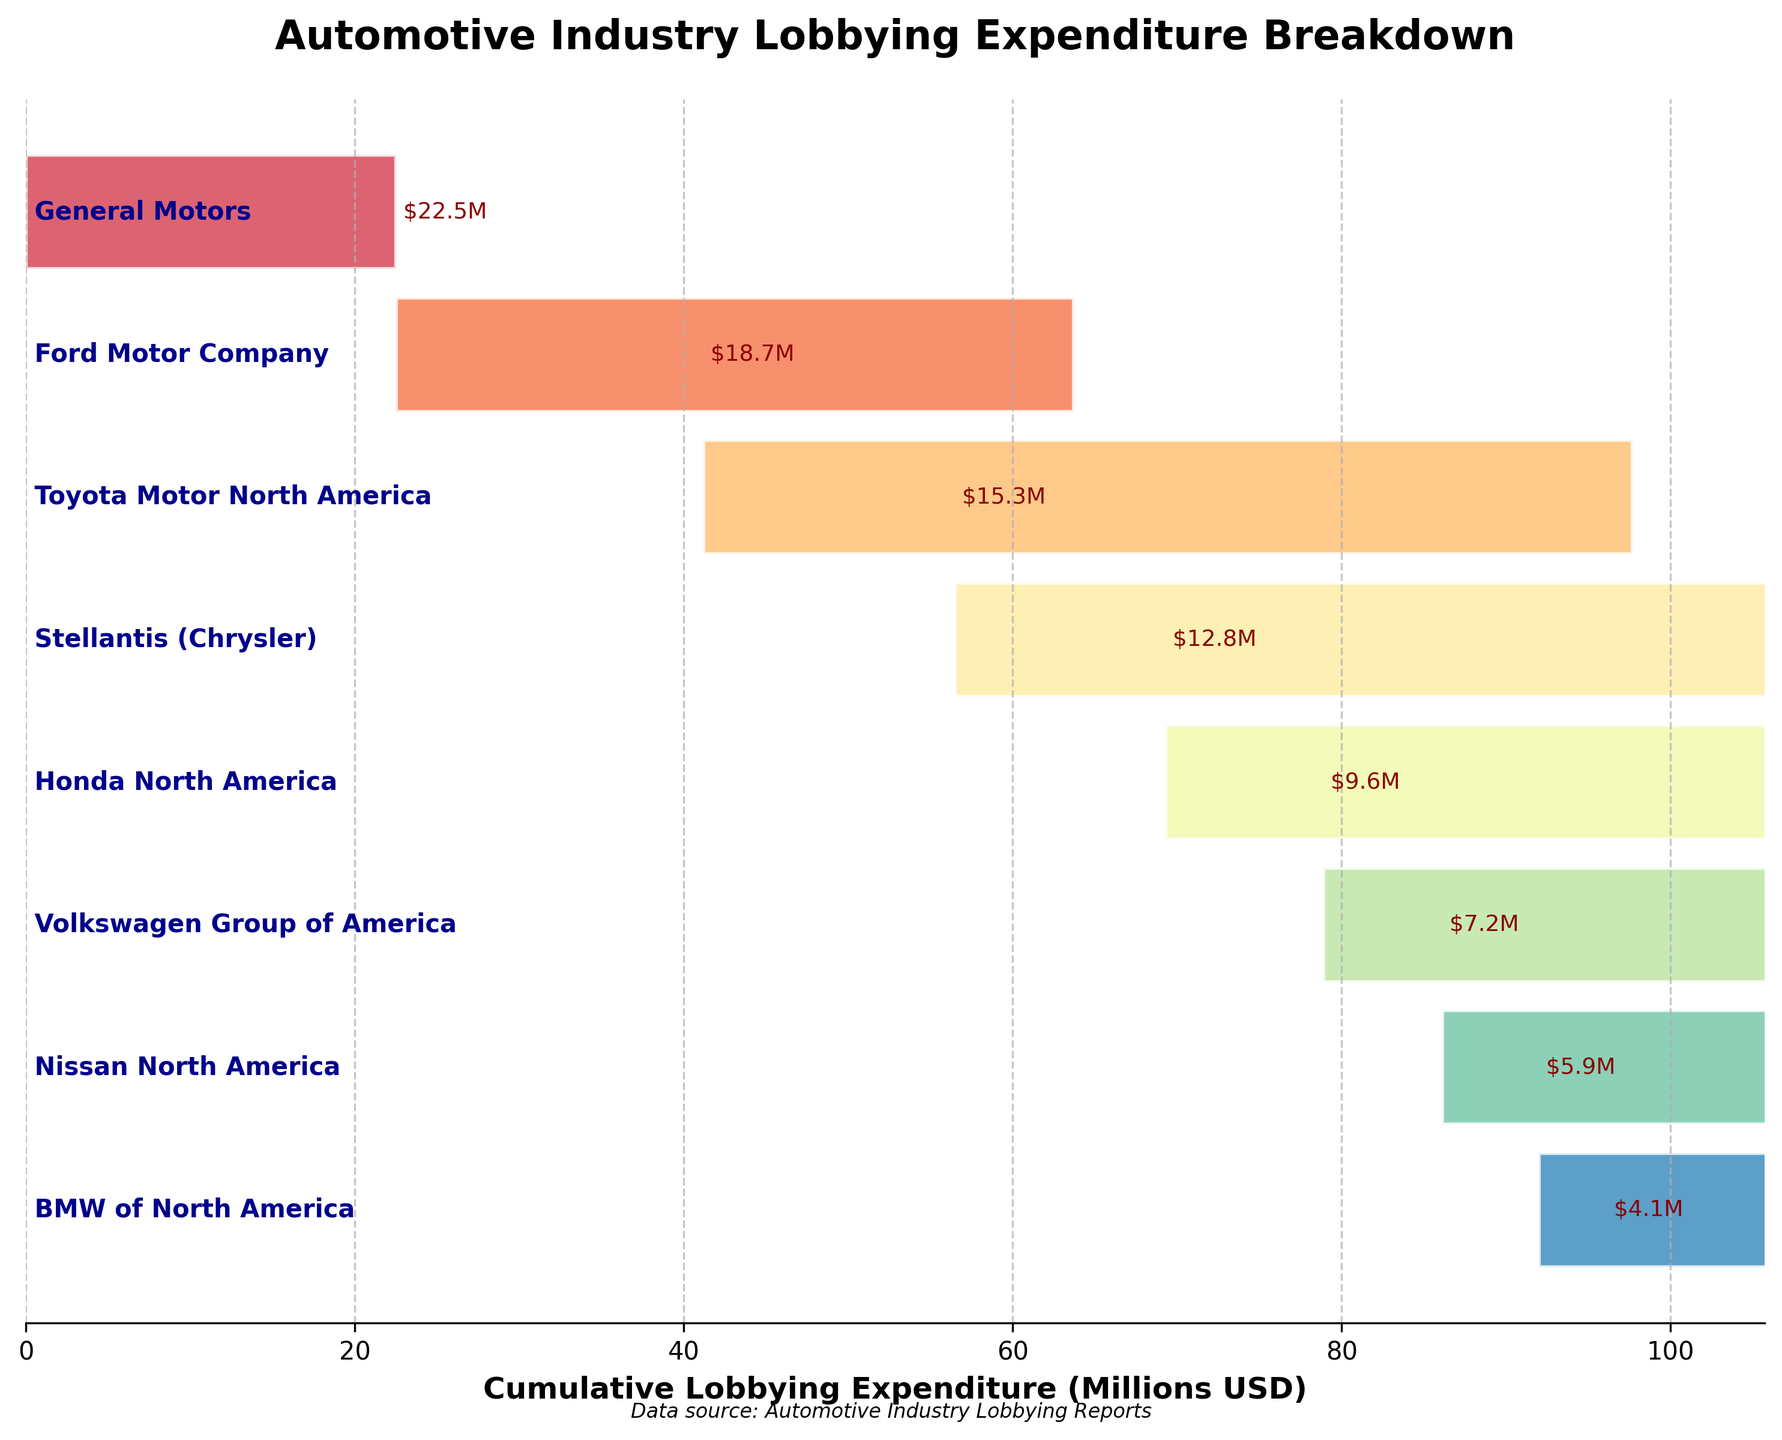What is the total lobbying expenditure of General Motors? The total lobbying expenditure of General Motors is directly given in the figure as $22.5M.
Answer: $22.5M Which company has the lowest lobbying expenditure? To find this, we look at the company with the smallest value in the funnel chart, which is BMW of North America with a lobbying expenditure of $4.1M.
Answer: BMW of North America How much more has General Motors spent on lobbying compared to Ford Motor Company? General Motors spent $22.5M, and Ford Motor Company spent $18.7M. The difference is $22.5M - $18.7M = $3.8M.
Answer: $3.8M Which company has the third highest lobbying expenditure? The chart shows General Motors, followed by Ford Motor Company, and then Toyota Motor North America. This makes Toyota Motor North America the third highest.
Answer: Toyota Motor North America What is the cumulative lobbying expenditure up to Stellantis (Chrysler)? Sum the expenditures for General Motors ($22.5M), Ford Motor Company ($18.7M), Toyota Motor North America ($15.3M), and Stellantis (Chrysler) ($12.8M): $22.5M + $18.7M + $15.3M + $12.8M = $69.3M.
Answer: $69.3M How does the lobbying expenditure of Honda North America compare to Volkswagen Group of America? Honda North America's expenditure is $9.6M, while Volkswagen Group of America's expenditure is $7.2M. Thus, Honda North American's expenditure is higher.
Answer: Higher What is the average lobbying expenditure of the top four companies? Sum the expenditures of the top four companies: General Motors ($22.5M), Ford Motor Company ($18.7M), Toyota Motor North America ($15.3M), and Stellantis (Chrysler) ($12.8M). The sum is $69.3M. Divide this by 4: $69.3M / 4 = $17.325M.
Answer: $17.325M What percentage of the total lobbying expenditure does Ford Motor Company account for? Ford Motor Company spent $18.7M. Sum all expenditures: $22.5M + $18.7M + $15.3M + $12.8M + $9.6M + $7.2M + $5.9M + $4.1M = $96.1M. Divide Ford's expenditure by the total and multiply by 100: ($18.7M / $96.1M) * 100 ≈ 19.5%.
Answer: 19.5% Between Nissan North America and BMW of North America, which has a higher lobbying expenditure and by how much? Nissan North America's expenditure is $5.9M, while BMW of North America's expenditure is $4.1M. The difference is $5.9M - $4.1M = $1.8M. So, Nissan North America has a higher expenditure.
Answer: Nissan North America, $1.8M What is the cumulative lobbying expenditure for all companies shown? Sum all expenditures: $22.5M + $18.7M + $15.3M + $12.8M + $9.6M + $7.2M + $5.9M + $4.1M = $96.1M.
Answer: $96.1M 